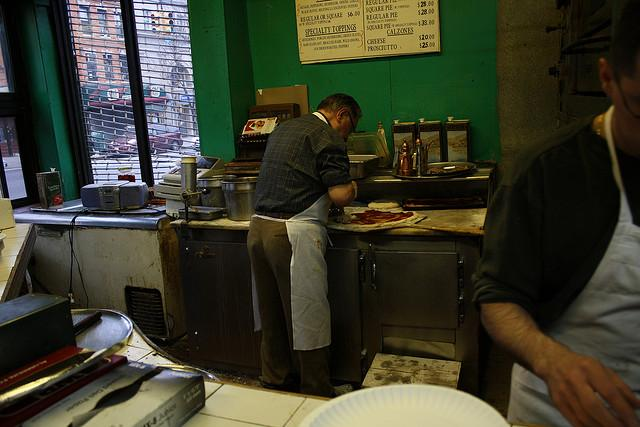Who regularly wore the item the man has over his pants? apron 